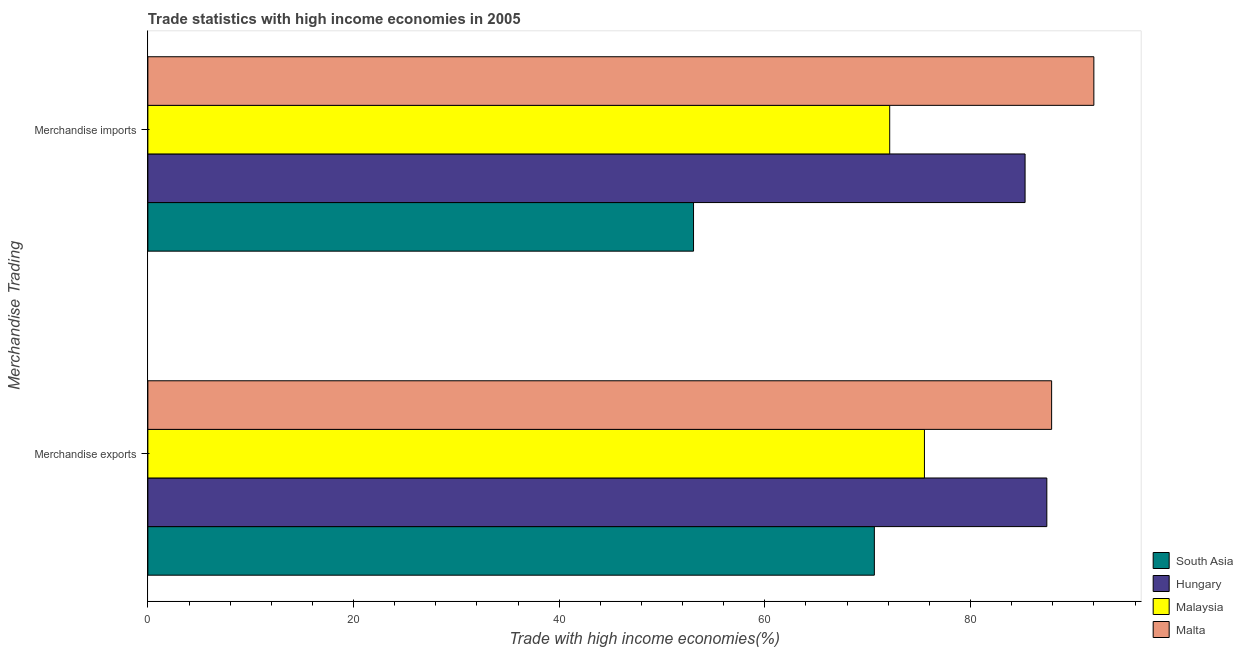How many different coloured bars are there?
Offer a very short reply. 4. How many groups of bars are there?
Offer a very short reply. 2. Are the number of bars per tick equal to the number of legend labels?
Offer a terse response. Yes. How many bars are there on the 1st tick from the top?
Your answer should be very brief. 4. What is the merchandise exports in Malta?
Ensure brevity in your answer.  87.89. Across all countries, what is the maximum merchandise exports?
Offer a terse response. 87.89. Across all countries, what is the minimum merchandise imports?
Provide a succinct answer. 53.07. In which country was the merchandise exports maximum?
Give a very brief answer. Malta. In which country was the merchandise exports minimum?
Make the answer very short. South Asia. What is the total merchandise imports in the graph?
Provide a short and direct response. 302.52. What is the difference between the merchandise imports in Hungary and that in Malaysia?
Ensure brevity in your answer.  13.17. What is the difference between the merchandise imports in Malta and the merchandise exports in Hungary?
Ensure brevity in your answer.  4.57. What is the average merchandise exports per country?
Keep it short and to the point. 80.37. What is the difference between the merchandise exports and merchandise imports in South Asia?
Your answer should be compact. 17.58. What is the ratio of the merchandise exports in Malta to that in South Asia?
Provide a succinct answer. 1.24. Is the merchandise imports in Malta less than that in South Asia?
Give a very brief answer. No. In how many countries, is the merchandise exports greater than the average merchandise exports taken over all countries?
Offer a very short reply. 2. What does the 3rd bar from the top in Merchandise exports represents?
Your response must be concise. Hungary. What does the 2nd bar from the bottom in Merchandise exports represents?
Keep it short and to the point. Hungary. What is the difference between two consecutive major ticks on the X-axis?
Your response must be concise. 20. Are the values on the major ticks of X-axis written in scientific E-notation?
Make the answer very short. No. Does the graph contain any zero values?
Offer a terse response. No. Does the graph contain grids?
Provide a succinct answer. No. How many legend labels are there?
Keep it short and to the point. 4. What is the title of the graph?
Make the answer very short. Trade statistics with high income economies in 2005. Does "Sudan" appear as one of the legend labels in the graph?
Offer a terse response. No. What is the label or title of the X-axis?
Your response must be concise. Trade with high income economies(%). What is the label or title of the Y-axis?
Provide a short and direct response. Merchandise Trading. What is the Trade with high income economies(%) of South Asia in Merchandise exports?
Your answer should be very brief. 70.65. What is the Trade with high income economies(%) of Hungary in Merchandise exports?
Provide a short and direct response. 87.42. What is the Trade with high income economies(%) of Malaysia in Merchandise exports?
Make the answer very short. 75.52. What is the Trade with high income economies(%) of Malta in Merchandise exports?
Provide a short and direct response. 87.89. What is the Trade with high income economies(%) of South Asia in Merchandise imports?
Give a very brief answer. 53.07. What is the Trade with high income economies(%) in Hungary in Merchandise imports?
Your answer should be very brief. 85.31. What is the Trade with high income economies(%) of Malaysia in Merchandise imports?
Offer a terse response. 72.14. What is the Trade with high income economies(%) in Malta in Merchandise imports?
Your answer should be very brief. 92. Across all Merchandise Trading, what is the maximum Trade with high income economies(%) in South Asia?
Make the answer very short. 70.65. Across all Merchandise Trading, what is the maximum Trade with high income economies(%) of Hungary?
Offer a very short reply. 87.42. Across all Merchandise Trading, what is the maximum Trade with high income economies(%) in Malaysia?
Your response must be concise. 75.52. Across all Merchandise Trading, what is the maximum Trade with high income economies(%) of Malta?
Provide a short and direct response. 92. Across all Merchandise Trading, what is the minimum Trade with high income economies(%) in South Asia?
Provide a succinct answer. 53.07. Across all Merchandise Trading, what is the minimum Trade with high income economies(%) in Hungary?
Offer a very short reply. 85.31. Across all Merchandise Trading, what is the minimum Trade with high income economies(%) of Malaysia?
Your answer should be compact. 72.14. Across all Merchandise Trading, what is the minimum Trade with high income economies(%) of Malta?
Your response must be concise. 87.89. What is the total Trade with high income economies(%) in South Asia in the graph?
Offer a very short reply. 123.72. What is the total Trade with high income economies(%) in Hungary in the graph?
Keep it short and to the point. 172.74. What is the total Trade with high income economies(%) in Malaysia in the graph?
Offer a terse response. 147.67. What is the total Trade with high income economies(%) of Malta in the graph?
Provide a short and direct response. 179.89. What is the difference between the Trade with high income economies(%) of South Asia in Merchandise exports and that in Merchandise imports?
Your answer should be compact. 17.58. What is the difference between the Trade with high income economies(%) in Hungary in Merchandise exports and that in Merchandise imports?
Keep it short and to the point. 2.11. What is the difference between the Trade with high income economies(%) in Malaysia in Merchandise exports and that in Merchandise imports?
Provide a short and direct response. 3.38. What is the difference between the Trade with high income economies(%) in Malta in Merchandise exports and that in Merchandise imports?
Give a very brief answer. -4.11. What is the difference between the Trade with high income economies(%) of South Asia in Merchandise exports and the Trade with high income economies(%) of Hungary in Merchandise imports?
Give a very brief answer. -14.66. What is the difference between the Trade with high income economies(%) in South Asia in Merchandise exports and the Trade with high income economies(%) in Malaysia in Merchandise imports?
Your response must be concise. -1.49. What is the difference between the Trade with high income economies(%) of South Asia in Merchandise exports and the Trade with high income economies(%) of Malta in Merchandise imports?
Your response must be concise. -21.35. What is the difference between the Trade with high income economies(%) of Hungary in Merchandise exports and the Trade with high income economies(%) of Malaysia in Merchandise imports?
Provide a short and direct response. 15.28. What is the difference between the Trade with high income economies(%) in Hungary in Merchandise exports and the Trade with high income economies(%) in Malta in Merchandise imports?
Ensure brevity in your answer.  -4.57. What is the difference between the Trade with high income economies(%) in Malaysia in Merchandise exports and the Trade with high income economies(%) in Malta in Merchandise imports?
Your response must be concise. -16.48. What is the average Trade with high income economies(%) of South Asia per Merchandise Trading?
Ensure brevity in your answer.  61.86. What is the average Trade with high income economies(%) of Hungary per Merchandise Trading?
Keep it short and to the point. 86.37. What is the average Trade with high income economies(%) of Malaysia per Merchandise Trading?
Offer a very short reply. 73.83. What is the average Trade with high income economies(%) of Malta per Merchandise Trading?
Your answer should be very brief. 89.95. What is the difference between the Trade with high income economies(%) of South Asia and Trade with high income economies(%) of Hungary in Merchandise exports?
Your answer should be very brief. -16.77. What is the difference between the Trade with high income economies(%) in South Asia and Trade with high income economies(%) in Malaysia in Merchandise exports?
Offer a very short reply. -4.87. What is the difference between the Trade with high income economies(%) of South Asia and Trade with high income economies(%) of Malta in Merchandise exports?
Your response must be concise. -17.24. What is the difference between the Trade with high income economies(%) of Hungary and Trade with high income economies(%) of Malaysia in Merchandise exports?
Ensure brevity in your answer.  11.9. What is the difference between the Trade with high income economies(%) in Hungary and Trade with high income economies(%) in Malta in Merchandise exports?
Your answer should be compact. -0.47. What is the difference between the Trade with high income economies(%) in Malaysia and Trade with high income economies(%) in Malta in Merchandise exports?
Your answer should be very brief. -12.37. What is the difference between the Trade with high income economies(%) of South Asia and Trade with high income economies(%) of Hungary in Merchandise imports?
Make the answer very short. -32.24. What is the difference between the Trade with high income economies(%) in South Asia and Trade with high income economies(%) in Malaysia in Merchandise imports?
Give a very brief answer. -19.08. What is the difference between the Trade with high income economies(%) in South Asia and Trade with high income economies(%) in Malta in Merchandise imports?
Offer a terse response. -38.93. What is the difference between the Trade with high income economies(%) in Hungary and Trade with high income economies(%) in Malaysia in Merchandise imports?
Your answer should be very brief. 13.17. What is the difference between the Trade with high income economies(%) of Hungary and Trade with high income economies(%) of Malta in Merchandise imports?
Provide a succinct answer. -6.69. What is the difference between the Trade with high income economies(%) of Malaysia and Trade with high income economies(%) of Malta in Merchandise imports?
Give a very brief answer. -19.86. What is the ratio of the Trade with high income economies(%) of South Asia in Merchandise exports to that in Merchandise imports?
Your answer should be very brief. 1.33. What is the ratio of the Trade with high income economies(%) of Hungary in Merchandise exports to that in Merchandise imports?
Your answer should be compact. 1.02. What is the ratio of the Trade with high income economies(%) in Malaysia in Merchandise exports to that in Merchandise imports?
Make the answer very short. 1.05. What is the ratio of the Trade with high income economies(%) in Malta in Merchandise exports to that in Merchandise imports?
Offer a terse response. 0.96. What is the difference between the highest and the second highest Trade with high income economies(%) of South Asia?
Your answer should be compact. 17.58. What is the difference between the highest and the second highest Trade with high income economies(%) in Hungary?
Provide a succinct answer. 2.11. What is the difference between the highest and the second highest Trade with high income economies(%) of Malaysia?
Provide a short and direct response. 3.38. What is the difference between the highest and the second highest Trade with high income economies(%) of Malta?
Provide a succinct answer. 4.11. What is the difference between the highest and the lowest Trade with high income economies(%) of South Asia?
Provide a succinct answer. 17.58. What is the difference between the highest and the lowest Trade with high income economies(%) of Hungary?
Your answer should be very brief. 2.11. What is the difference between the highest and the lowest Trade with high income economies(%) in Malaysia?
Ensure brevity in your answer.  3.38. What is the difference between the highest and the lowest Trade with high income economies(%) of Malta?
Offer a very short reply. 4.11. 